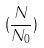<formula> <loc_0><loc_0><loc_500><loc_500>( \frac { N } { N _ { 0 } } )</formula> 